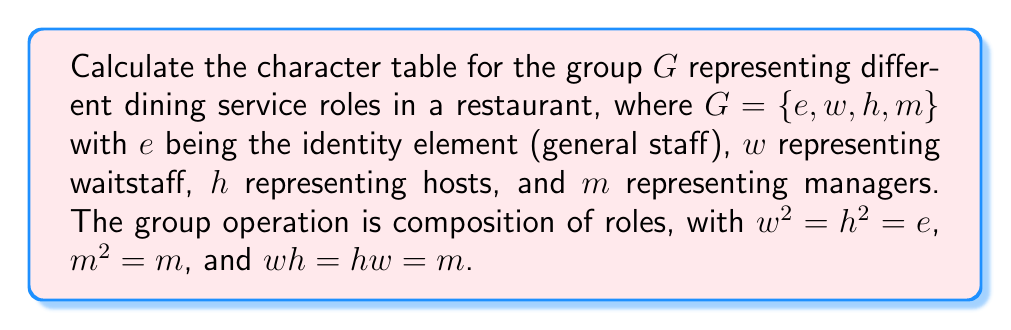What is the answer to this math problem? To calculate the character table for this group, we'll follow these steps:

1. Determine the conjugacy classes:
   - $\{e\}$: identity
   - $\{w, h\}$: waitstaff and hosts (they're conjugate since $mwm^{-1} = h$)
   - $\{m\}$: manager

2. Find the number of irreducible representations:
   The number of irreducible representations equals the number of conjugacy classes, which is 3.

3. Determine the dimensions of the irreducible representations:
   We know that $\sum_i d_i^2 = |G| = 4$, where $d_i$ are the dimensions.
   The only possibility is $1^2 + 1^2 + 2^2 = 4$.

4. Construct the character table:
   - Let $\chi_1$ be the trivial representation.
   - Let $\chi_2$ be the sign representation for $\{w, h\}$.
   - Let $\chi_3$ be the 2-dimensional representation.

5. Fill in the character table:
   - For $\chi_1$: All characters are 1.
   - For $\chi_2$: $\chi_2(e) = 1$, $\chi_2(w) = \chi_2(h) = -1$, $\chi_2(m) = 1$.
   - For $\chi_3$: 
     $\chi_3(e) = 2$ (trace of 2x2 identity matrix)
     $\chi_3(w) = \chi_3(h) = 0$ (trace of matrix with eigenvalues 1 and -1)
     $\chi_3(m) = -1$ (trace of matrix with eigenvalues 1 and -1, since $m^2 = m$)

6. Verify orthogonality relations:
   This step is omitted for brevity, but it's crucial to ensure the table is correct.

The resulting character table is:

$$
\begin{array}{c|cccc}
G & e & w,h & m \\
\hline
\chi_1 & 1 & 1 & 1 \\
\chi_2 & 1 & -1 & 1 \\
\chi_3 & 2 & 0 & -1
\end{array}
$$
Answer: $$
\begin{array}{c|cccc}
G & e & w,h & m \\
\hline
\chi_1 & 1 & 1 & 1 \\
\chi_2 & 1 & -1 & 1 \\
\chi_3 & 2 & 0 & -1
\end{array}
$$ 